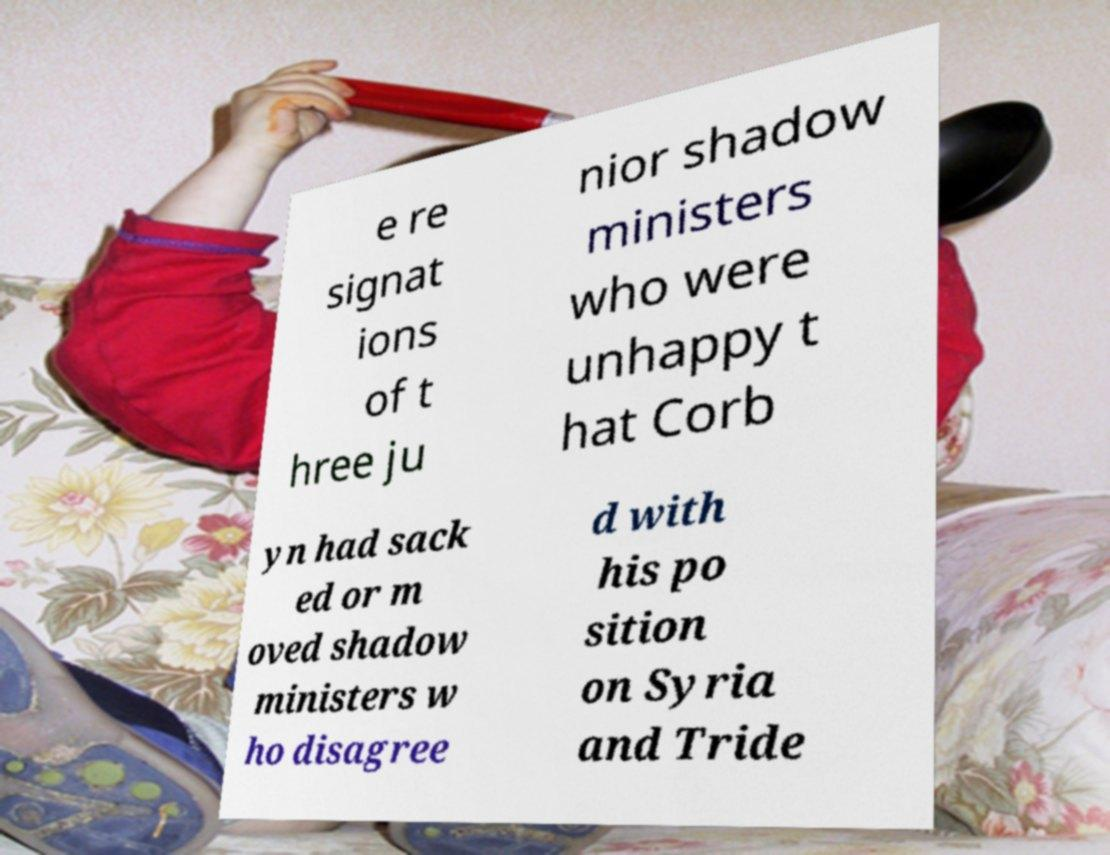Please identify and transcribe the text found in this image. e re signat ions of t hree ju nior shadow ministers who were unhappy t hat Corb yn had sack ed or m oved shadow ministers w ho disagree d with his po sition on Syria and Tride 